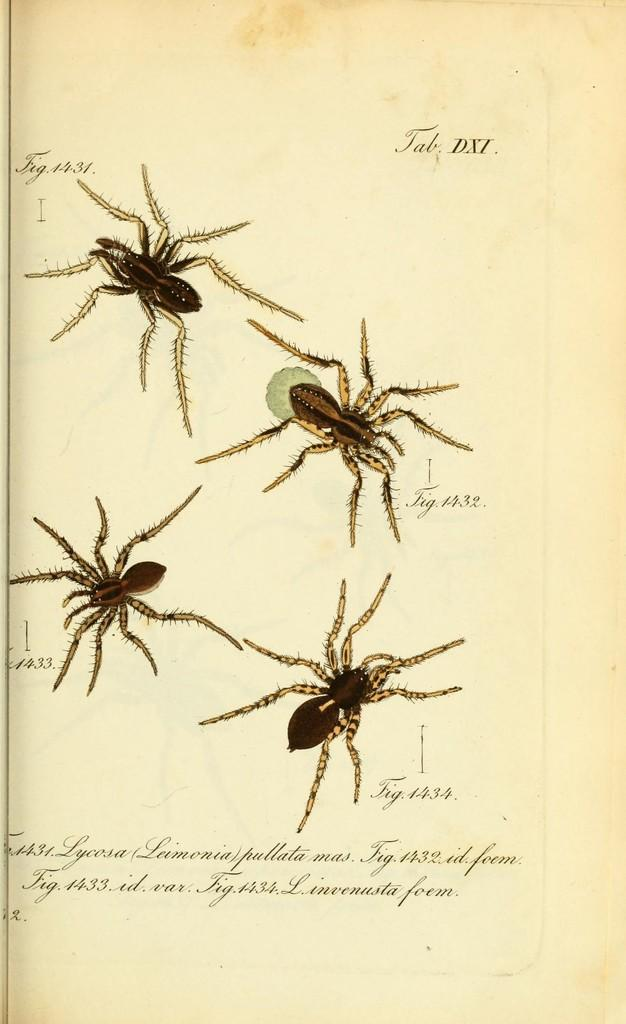What creatures are present in the image? There are spiders in the image. What can be found at the bottom of the image? There is text at the bottom of the image. How was the image created? The image is painted. What type of drum is being played in the image? There is no drum present in the image; it features spiders and text. 